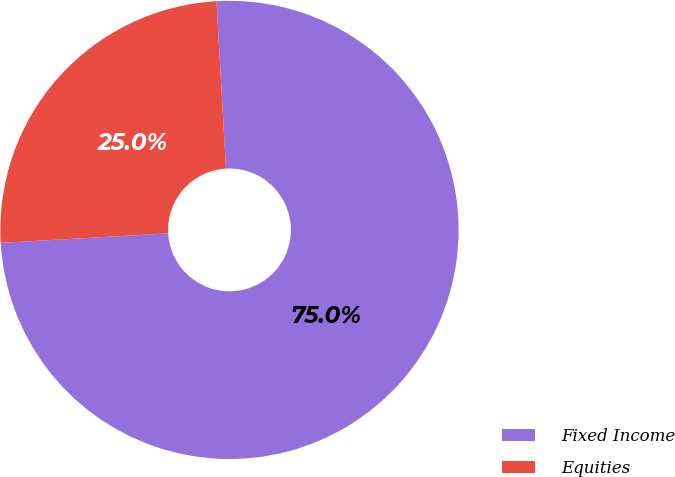Convert chart to OTSL. <chart><loc_0><loc_0><loc_500><loc_500><pie_chart><fcel>Fixed Income<fcel>Equities<nl><fcel>75.0%<fcel>25.0%<nl></chart> 